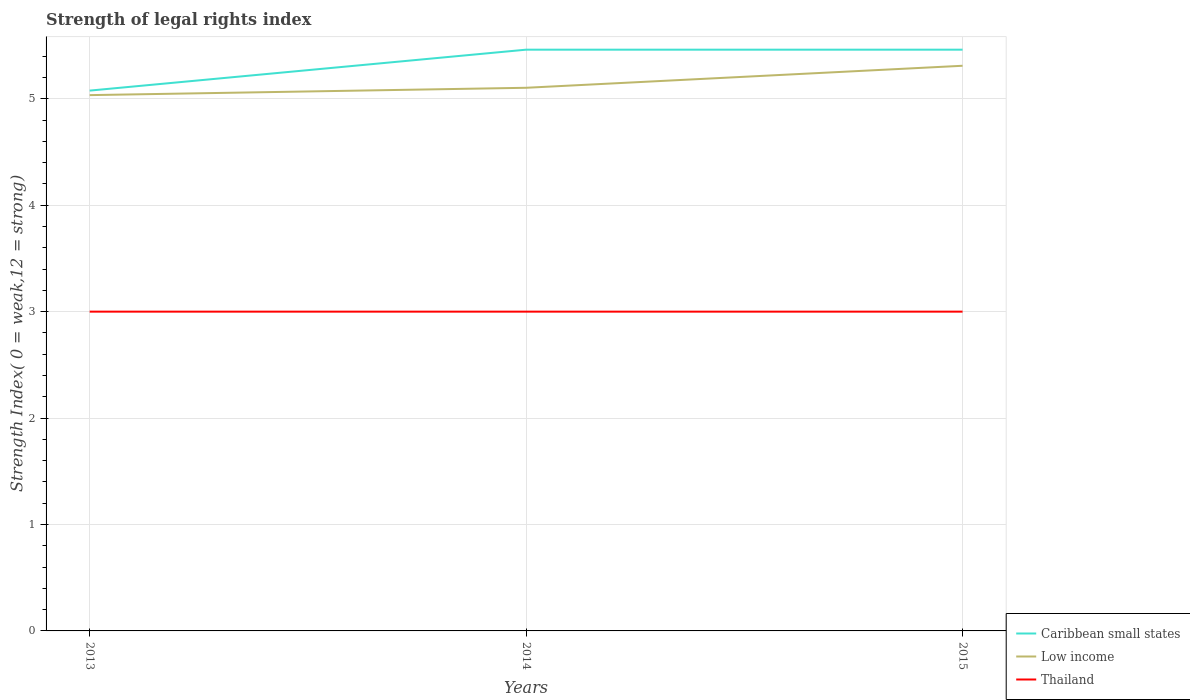How many different coloured lines are there?
Your response must be concise. 3. Across all years, what is the maximum strength index in Thailand?
Ensure brevity in your answer.  3. In which year was the strength index in Thailand maximum?
Keep it short and to the point. 2013. What is the total strength index in Low income in the graph?
Keep it short and to the point. -0.07. What is the difference between the highest and the second highest strength index in Caribbean small states?
Your response must be concise. 0.38. How many lines are there?
Offer a very short reply. 3. Does the graph contain grids?
Ensure brevity in your answer.  Yes. How many legend labels are there?
Give a very brief answer. 3. How are the legend labels stacked?
Your response must be concise. Vertical. What is the title of the graph?
Offer a terse response. Strength of legal rights index. What is the label or title of the Y-axis?
Your answer should be compact. Strength Index( 0 = weak,12 = strong). What is the Strength Index( 0 = weak,12 = strong) in Caribbean small states in 2013?
Your response must be concise. 5.08. What is the Strength Index( 0 = weak,12 = strong) of Low income in 2013?
Offer a very short reply. 5.03. What is the Strength Index( 0 = weak,12 = strong) in Caribbean small states in 2014?
Offer a terse response. 5.46. What is the Strength Index( 0 = weak,12 = strong) in Low income in 2014?
Keep it short and to the point. 5.1. What is the Strength Index( 0 = weak,12 = strong) of Caribbean small states in 2015?
Provide a short and direct response. 5.46. What is the Strength Index( 0 = weak,12 = strong) of Low income in 2015?
Your answer should be very brief. 5.31. Across all years, what is the maximum Strength Index( 0 = weak,12 = strong) of Caribbean small states?
Ensure brevity in your answer.  5.46. Across all years, what is the maximum Strength Index( 0 = weak,12 = strong) of Low income?
Offer a terse response. 5.31. Across all years, what is the minimum Strength Index( 0 = weak,12 = strong) of Caribbean small states?
Offer a terse response. 5.08. Across all years, what is the minimum Strength Index( 0 = weak,12 = strong) in Low income?
Offer a terse response. 5.03. What is the total Strength Index( 0 = weak,12 = strong) in Low income in the graph?
Provide a succinct answer. 15.45. What is the total Strength Index( 0 = weak,12 = strong) in Thailand in the graph?
Offer a very short reply. 9. What is the difference between the Strength Index( 0 = weak,12 = strong) of Caribbean small states in 2013 and that in 2014?
Offer a terse response. -0.38. What is the difference between the Strength Index( 0 = weak,12 = strong) in Low income in 2013 and that in 2014?
Offer a very short reply. -0.07. What is the difference between the Strength Index( 0 = weak,12 = strong) in Thailand in 2013 and that in 2014?
Provide a succinct answer. 0. What is the difference between the Strength Index( 0 = weak,12 = strong) of Caribbean small states in 2013 and that in 2015?
Your answer should be compact. -0.38. What is the difference between the Strength Index( 0 = weak,12 = strong) of Low income in 2013 and that in 2015?
Make the answer very short. -0.28. What is the difference between the Strength Index( 0 = weak,12 = strong) of Thailand in 2013 and that in 2015?
Make the answer very short. 0. What is the difference between the Strength Index( 0 = weak,12 = strong) of Low income in 2014 and that in 2015?
Provide a short and direct response. -0.21. What is the difference between the Strength Index( 0 = weak,12 = strong) of Caribbean small states in 2013 and the Strength Index( 0 = weak,12 = strong) of Low income in 2014?
Provide a succinct answer. -0.03. What is the difference between the Strength Index( 0 = weak,12 = strong) of Caribbean small states in 2013 and the Strength Index( 0 = weak,12 = strong) of Thailand in 2014?
Your answer should be compact. 2.08. What is the difference between the Strength Index( 0 = weak,12 = strong) of Low income in 2013 and the Strength Index( 0 = weak,12 = strong) of Thailand in 2014?
Keep it short and to the point. 2.03. What is the difference between the Strength Index( 0 = weak,12 = strong) of Caribbean small states in 2013 and the Strength Index( 0 = weak,12 = strong) of Low income in 2015?
Your answer should be compact. -0.23. What is the difference between the Strength Index( 0 = weak,12 = strong) in Caribbean small states in 2013 and the Strength Index( 0 = weak,12 = strong) in Thailand in 2015?
Your answer should be very brief. 2.08. What is the difference between the Strength Index( 0 = weak,12 = strong) of Low income in 2013 and the Strength Index( 0 = weak,12 = strong) of Thailand in 2015?
Keep it short and to the point. 2.03. What is the difference between the Strength Index( 0 = weak,12 = strong) in Caribbean small states in 2014 and the Strength Index( 0 = weak,12 = strong) in Low income in 2015?
Offer a terse response. 0.15. What is the difference between the Strength Index( 0 = weak,12 = strong) in Caribbean small states in 2014 and the Strength Index( 0 = weak,12 = strong) in Thailand in 2015?
Offer a very short reply. 2.46. What is the difference between the Strength Index( 0 = weak,12 = strong) in Low income in 2014 and the Strength Index( 0 = weak,12 = strong) in Thailand in 2015?
Your answer should be compact. 2.1. What is the average Strength Index( 0 = weak,12 = strong) of Caribbean small states per year?
Provide a succinct answer. 5.33. What is the average Strength Index( 0 = weak,12 = strong) of Low income per year?
Your answer should be very brief. 5.15. What is the average Strength Index( 0 = weak,12 = strong) of Thailand per year?
Provide a succinct answer. 3. In the year 2013, what is the difference between the Strength Index( 0 = weak,12 = strong) of Caribbean small states and Strength Index( 0 = weak,12 = strong) of Low income?
Your answer should be very brief. 0.04. In the year 2013, what is the difference between the Strength Index( 0 = weak,12 = strong) in Caribbean small states and Strength Index( 0 = weak,12 = strong) in Thailand?
Offer a terse response. 2.08. In the year 2013, what is the difference between the Strength Index( 0 = weak,12 = strong) of Low income and Strength Index( 0 = weak,12 = strong) of Thailand?
Ensure brevity in your answer.  2.03. In the year 2014, what is the difference between the Strength Index( 0 = weak,12 = strong) in Caribbean small states and Strength Index( 0 = weak,12 = strong) in Low income?
Provide a short and direct response. 0.36. In the year 2014, what is the difference between the Strength Index( 0 = weak,12 = strong) of Caribbean small states and Strength Index( 0 = weak,12 = strong) of Thailand?
Offer a terse response. 2.46. In the year 2014, what is the difference between the Strength Index( 0 = weak,12 = strong) of Low income and Strength Index( 0 = weak,12 = strong) of Thailand?
Offer a terse response. 2.1. In the year 2015, what is the difference between the Strength Index( 0 = weak,12 = strong) of Caribbean small states and Strength Index( 0 = weak,12 = strong) of Low income?
Offer a terse response. 0.15. In the year 2015, what is the difference between the Strength Index( 0 = weak,12 = strong) in Caribbean small states and Strength Index( 0 = weak,12 = strong) in Thailand?
Your answer should be compact. 2.46. In the year 2015, what is the difference between the Strength Index( 0 = weak,12 = strong) in Low income and Strength Index( 0 = weak,12 = strong) in Thailand?
Ensure brevity in your answer.  2.31. What is the ratio of the Strength Index( 0 = weak,12 = strong) in Caribbean small states in 2013 to that in 2014?
Your answer should be very brief. 0.93. What is the ratio of the Strength Index( 0 = weak,12 = strong) of Low income in 2013 to that in 2014?
Offer a terse response. 0.99. What is the ratio of the Strength Index( 0 = weak,12 = strong) of Thailand in 2013 to that in 2014?
Ensure brevity in your answer.  1. What is the ratio of the Strength Index( 0 = weak,12 = strong) in Caribbean small states in 2013 to that in 2015?
Offer a very short reply. 0.93. What is the ratio of the Strength Index( 0 = weak,12 = strong) of Low income in 2013 to that in 2015?
Offer a terse response. 0.95. What is the ratio of the Strength Index( 0 = weak,12 = strong) in Thailand in 2014 to that in 2015?
Provide a succinct answer. 1. What is the difference between the highest and the second highest Strength Index( 0 = weak,12 = strong) of Caribbean small states?
Your answer should be very brief. 0. What is the difference between the highest and the second highest Strength Index( 0 = weak,12 = strong) of Low income?
Give a very brief answer. 0.21. What is the difference between the highest and the second highest Strength Index( 0 = weak,12 = strong) in Thailand?
Give a very brief answer. 0. What is the difference between the highest and the lowest Strength Index( 0 = weak,12 = strong) of Caribbean small states?
Provide a succinct answer. 0.38. What is the difference between the highest and the lowest Strength Index( 0 = weak,12 = strong) of Low income?
Provide a succinct answer. 0.28. What is the difference between the highest and the lowest Strength Index( 0 = weak,12 = strong) of Thailand?
Make the answer very short. 0. 